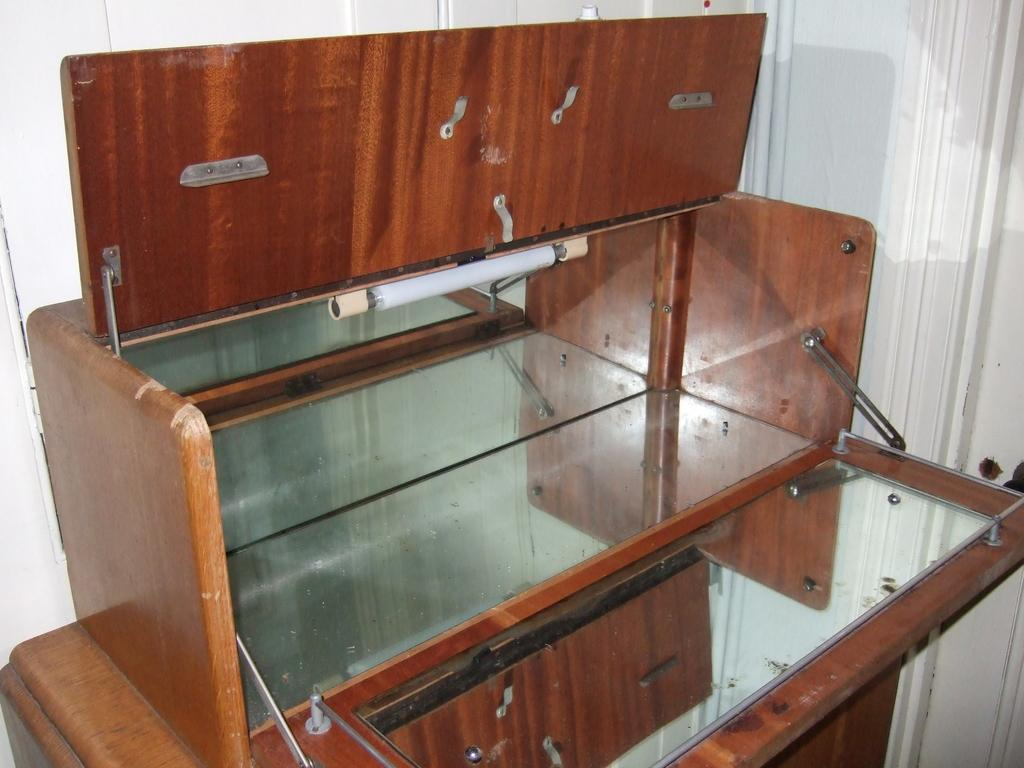What color is the background of the image? The background of the image is white. What type of furniture is present in the image? There is a wooden cupboard in the image. What object is used for reflecting images in the image? There is a mirror in the image. What source of illumination is visible in the image? There is a light in the image. What type of musical instrument is being played in the image? There is no musical instrument or indication of music being played in the image. 